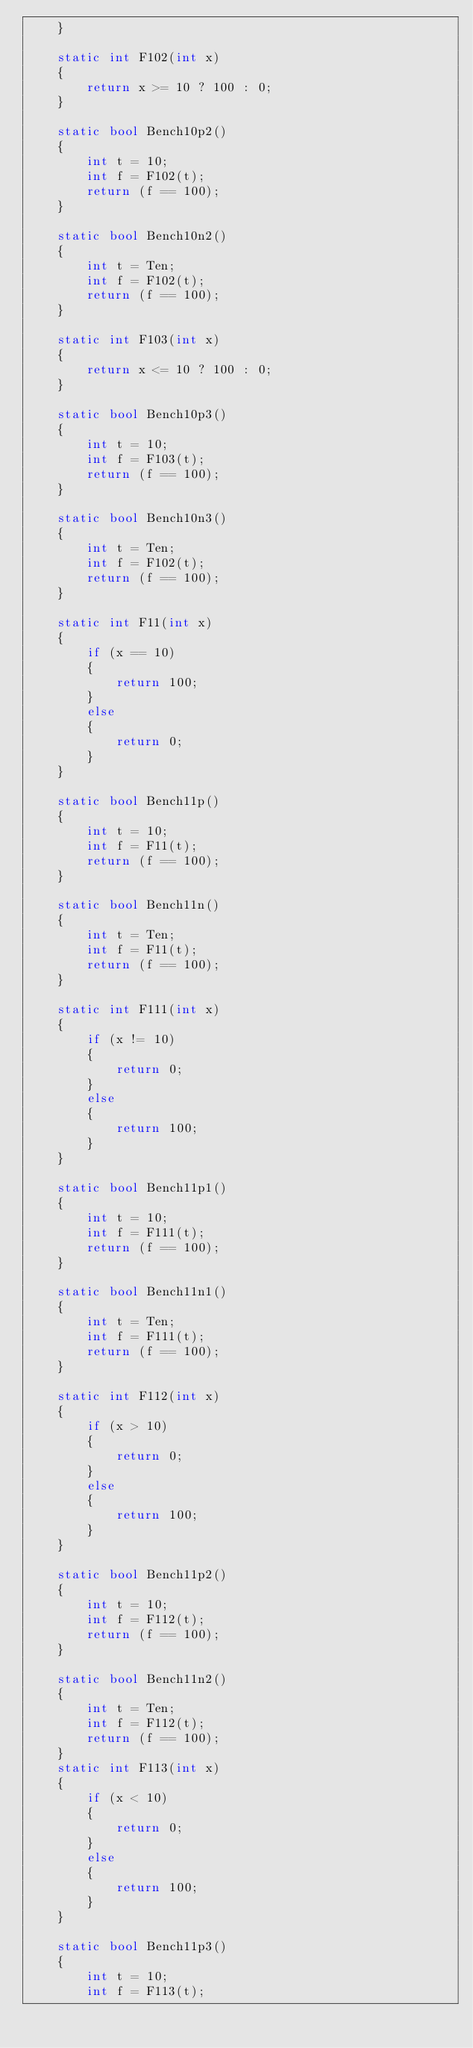<code> <loc_0><loc_0><loc_500><loc_500><_C#_>    }

    static int F102(int x)
    {
        return x >= 10 ? 100 : 0;
    }

    static bool Bench10p2()
    {
        int t = 10;
        int f = F102(t);
        return (f == 100);
    }

    static bool Bench10n2()
    {
        int t = Ten;
        int f = F102(t);
        return (f == 100);
    }

    static int F103(int x)
    {
        return x <= 10 ? 100 : 0;
    }

    static bool Bench10p3()
    {
        int t = 10;
        int f = F103(t);
        return (f == 100);
    }

    static bool Bench10n3()
    {
        int t = Ten;
        int f = F102(t);
        return (f == 100);
    }

    static int F11(int x)
    {
        if (x == 10)
        {
            return 100;
        }
        else
        {
            return 0;
        }
    }

    static bool Bench11p()
    {
        int t = 10;
        int f = F11(t);
        return (f == 100);
    }

    static bool Bench11n()
    {
        int t = Ten;
        int f = F11(t);
        return (f == 100);
    }

    static int F111(int x)
    {
        if (x != 10)
        {
            return 0;
        }
        else
        {
            return 100;
        }
    }

    static bool Bench11p1()
    {
        int t = 10;
        int f = F111(t);
        return (f == 100);
    }

    static bool Bench11n1()
    {
        int t = Ten;
        int f = F111(t);
        return (f == 100);
    }

    static int F112(int x)
    {
        if (x > 10)
        {
            return 0;
        }
        else
        {
            return 100;
        }
    }

    static bool Bench11p2()
    {
        int t = 10;
        int f = F112(t);
        return (f == 100);
    }

    static bool Bench11n2()
    {
        int t = Ten;
        int f = F112(t);
        return (f == 100);
    }
    static int F113(int x)
    {
        if (x < 10)
        {
            return 0;
        }
        else
        {
            return 100;
        }
    }

    static bool Bench11p3()
    {
        int t = 10;
        int f = F113(t);</code> 